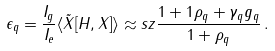Convert formula to latex. <formula><loc_0><loc_0><loc_500><loc_500>\epsilon _ { q } = \frac { I _ { g } } { I _ { e } } \langle \tilde { X } [ H , X ] \rangle \approx s z \frac { 1 + 1 \rho _ { q } + \gamma _ { q } g _ { q } } { 1 + \rho _ { q } } \, .</formula> 